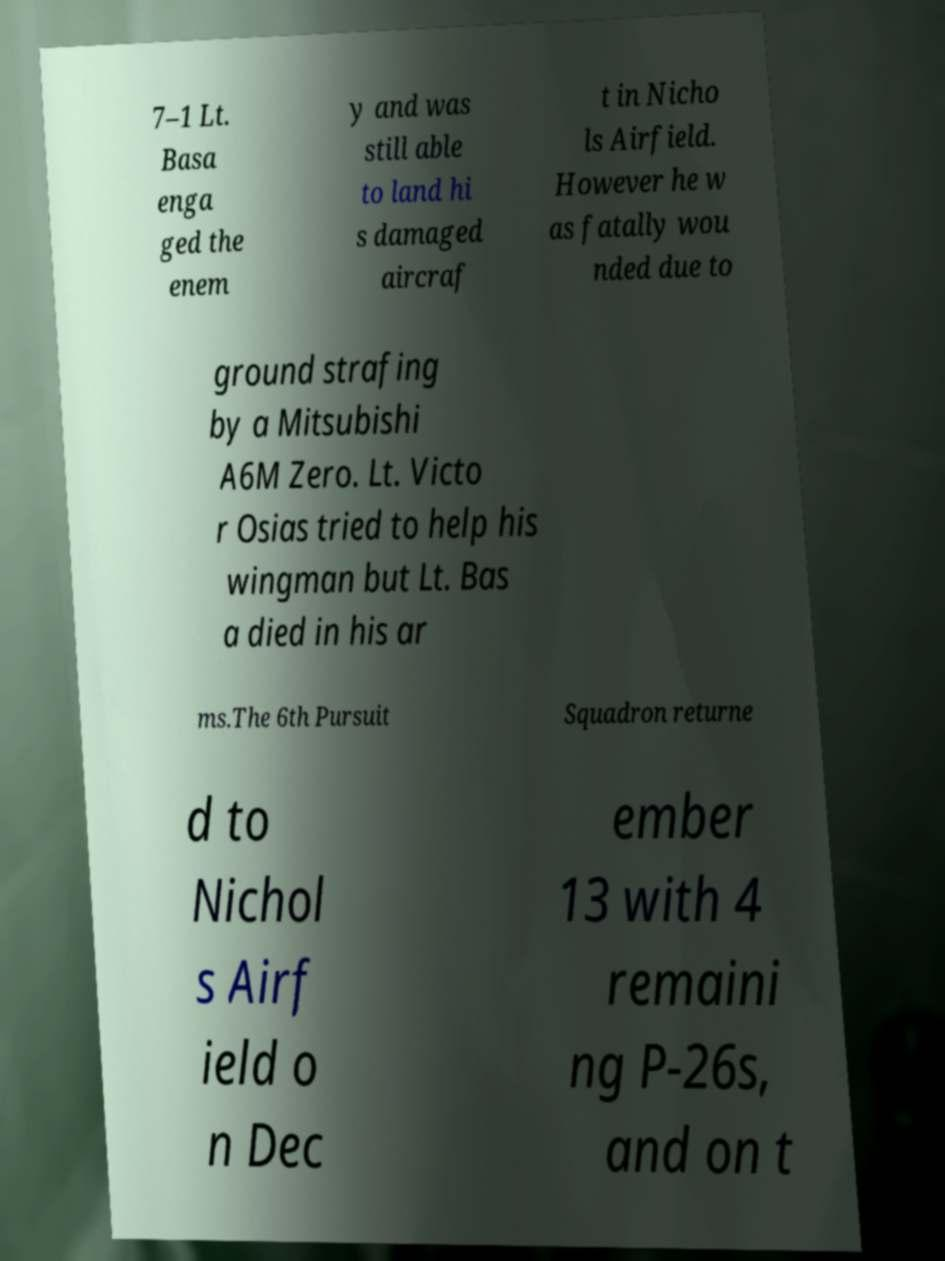Can you accurately transcribe the text from the provided image for me? 7–1 Lt. Basa enga ged the enem y and was still able to land hi s damaged aircraf t in Nicho ls Airfield. However he w as fatally wou nded due to ground strafing by a Mitsubishi A6M Zero. Lt. Victo r Osias tried to help his wingman but Lt. Bas a died in his ar ms.The 6th Pursuit Squadron returne d to Nichol s Airf ield o n Dec ember 13 with 4 remaini ng P-26s, and on t 